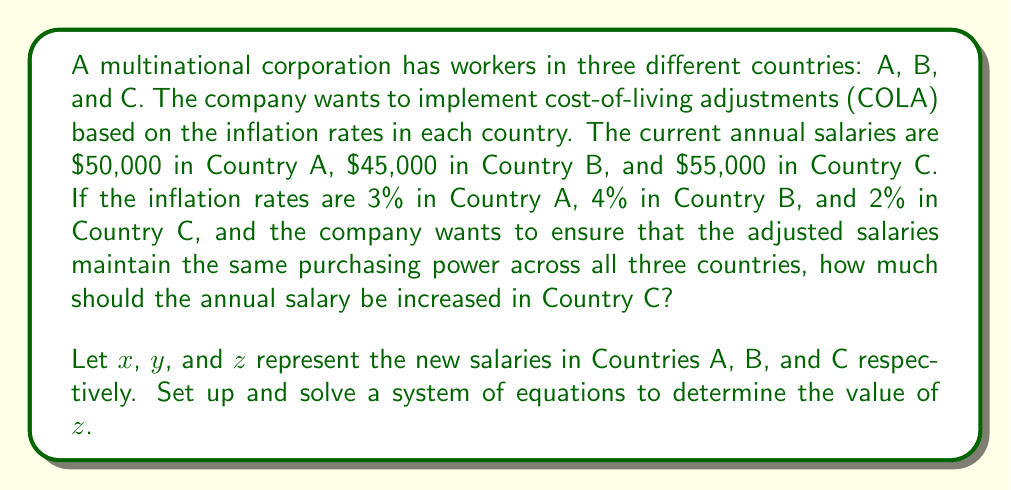Could you help me with this problem? To solve this problem, we need to set up a system of equations that represents the adjusted salaries in each country. The goal is to maintain equal purchasing power across all three countries after adjusting for inflation.

Step 1: Set up the equations
For Country A: $x = 50000 \times 1.03 = 51500$
For Country B: $y = 45000 \times 1.04 = 46800$
For Country C: $z = 55000 \times (1 + r)$, where $r$ is the rate of increase we need to find

Step 2: Create equations to equalize purchasing power
We need the ratios of the new salaries to be equal to the ratios of the original salaries:

$$\frac{x}{50000} = \frac{y}{45000} = \frac{z}{55000}$$

Step 3: Substitute known values and simplify
$$\frac{51500}{50000} = \frac{46800}{45000} = \frac{z}{55000}$$

$$1.03 = 1.04 = \frac{z}{55000}$$

Step 4: Solve for $z$
$$\frac{z}{55000} = 1.04$$
$$z = 55000 \times 1.04 = 57200$$

Step 5: Calculate the increase
Increase = New salary - Original salary
$$57200 - 55000 = 2200$$

Therefore, the annual salary in Country C should be increased by $2,200.
Answer: $2,200 